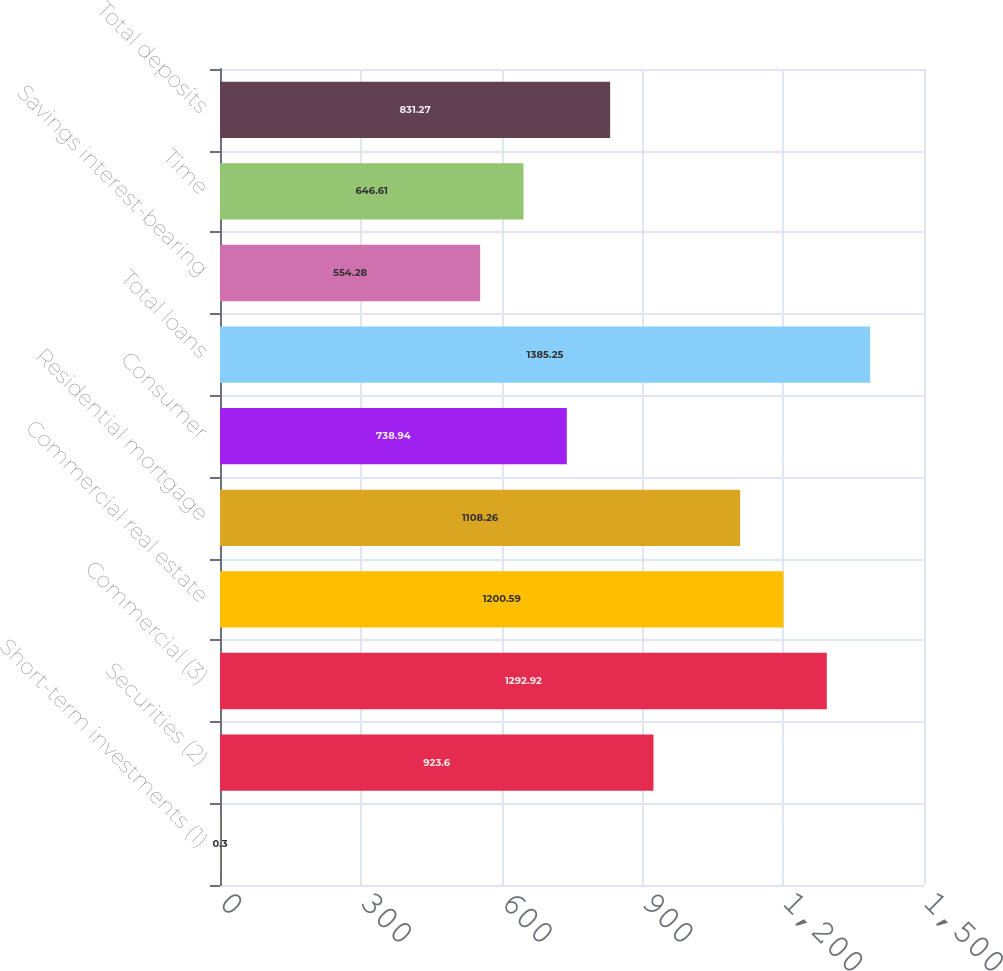Convert chart to OTSL. <chart><loc_0><loc_0><loc_500><loc_500><bar_chart><fcel>Short-term investments (1)<fcel>Securities (2)<fcel>Commercial (3)<fcel>Commercial real estate<fcel>Residential mortgage<fcel>Consumer<fcel>Total loans<fcel>Savings interest-bearing<fcel>Time<fcel>Total deposits<nl><fcel>0.3<fcel>923.6<fcel>1292.92<fcel>1200.59<fcel>1108.26<fcel>738.94<fcel>1385.25<fcel>554.28<fcel>646.61<fcel>831.27<nl></chart> 